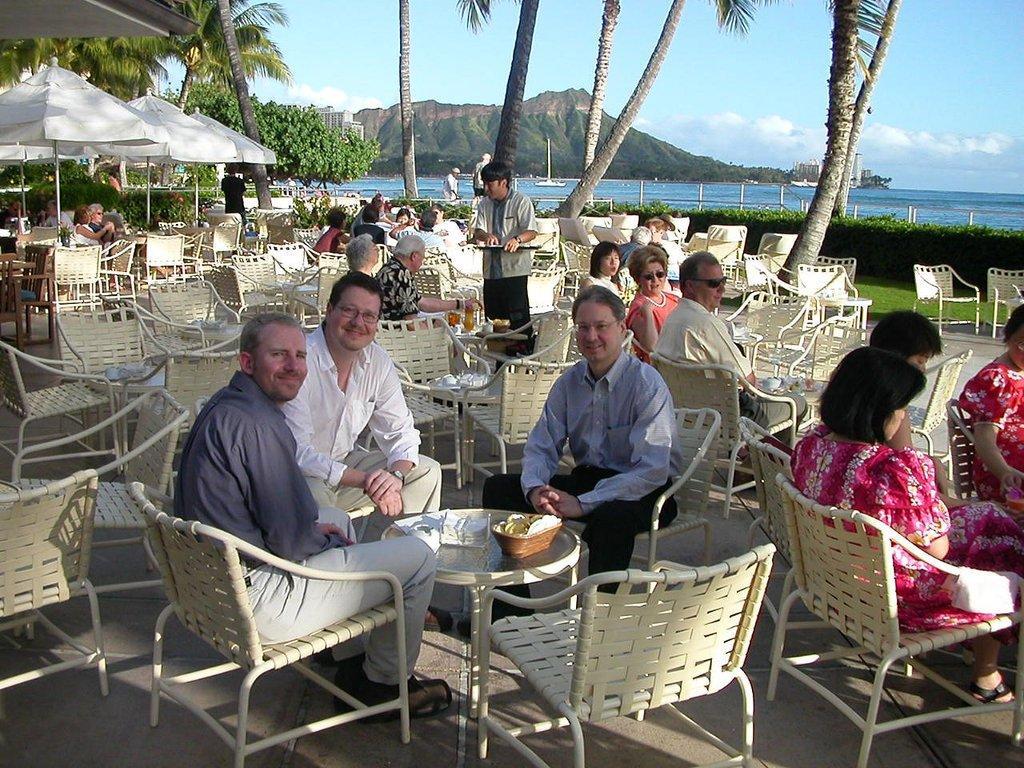Could you give a brief overview of what you see in this image? In this picture we can find three men staring at the person who is taking the photograph. They have a table before them and the table has some tissues. There are some people behind them, there is a woman speaking. And their is a waiter taking the order, and there are some trees and a mountain, sea and the sky is clear with some clouds. 